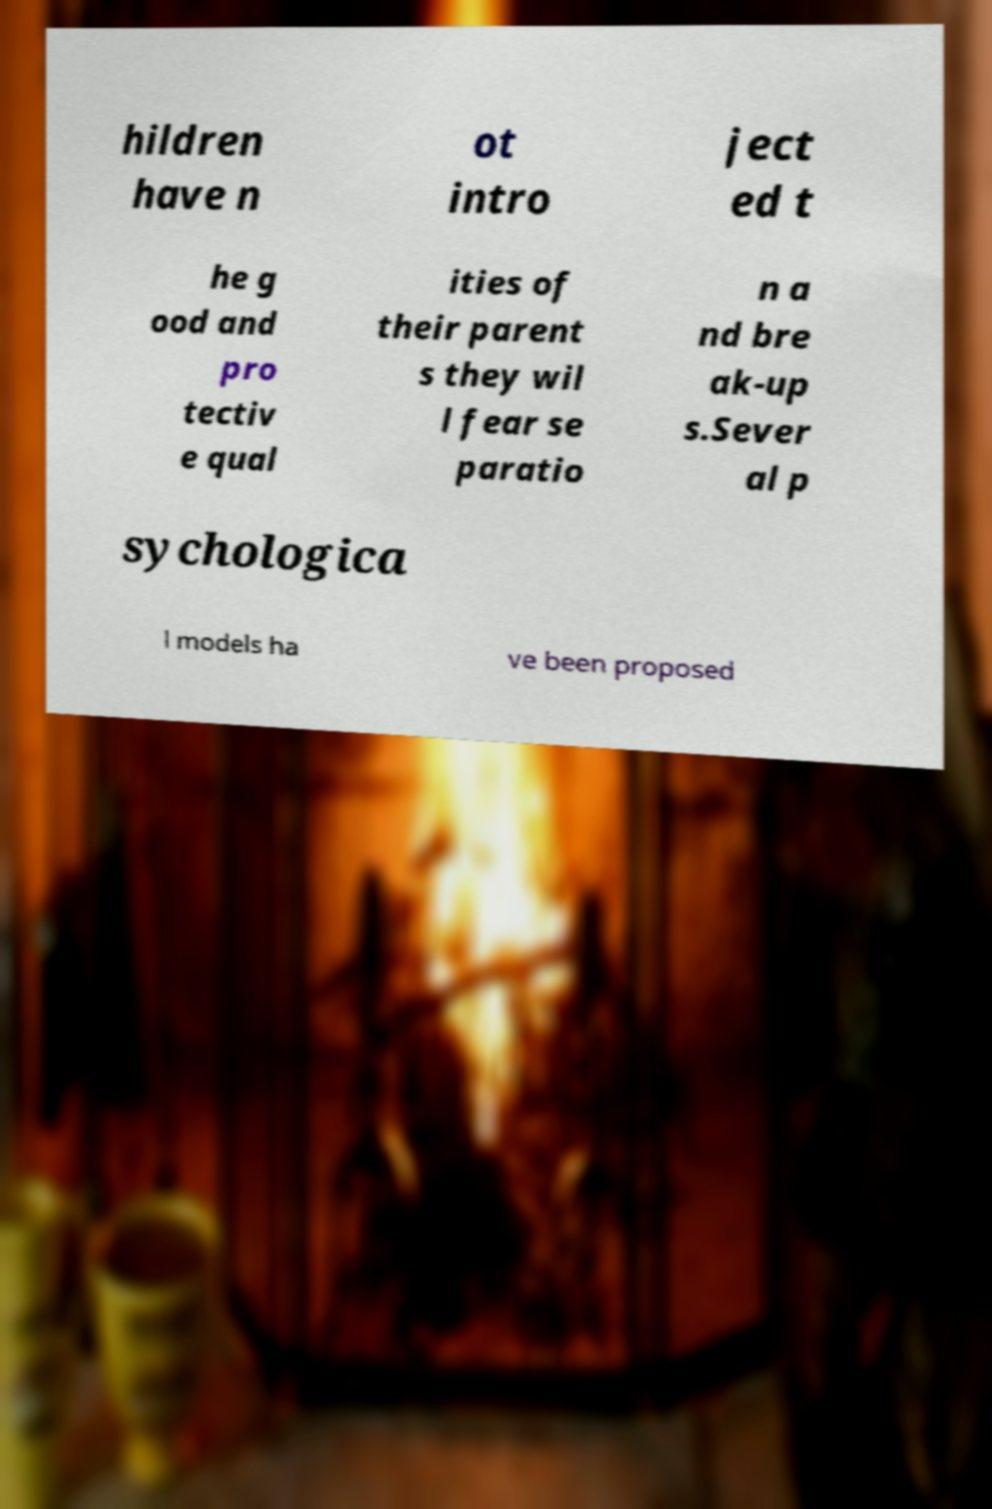Please read and relay the text visible in this image. What does it say? hildren have n ot intro ject ed t he g ood and pro tectiv e qual ities of their parent s they wil l fear se paratio n a nd bre ak-up s.Sever al p sychologica l models ha ve been proposed 